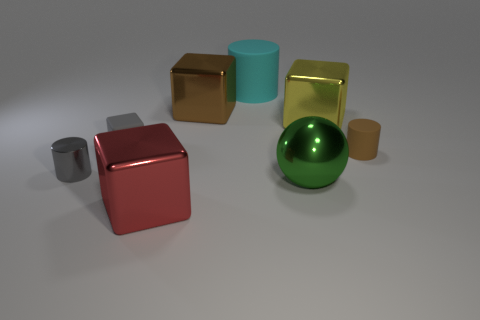Subtract all big cylinders. How many cylinders are left? 2 Subtract 2 cubes. How many cubes are left? 2 Subtract all brown blocks. How many blocks are left? 3 Add 1 small brown rubber objects. How many objects exist? 9 Subtract all blue blocks. Subtract all blue balls. How many blocks are left? 4 Subtract all spheres. How many objects are left? 7 Subtract all big objects. Subtract all gray cylinders. How many objects are left? 2 Add 3 cyan matte objects. How many cyan matte objects are left? 4 Add 8 shiny cylinders. How many shiny cylinders exist? 9 Subtract 0 cyan cubes. How many objects are left? 8 